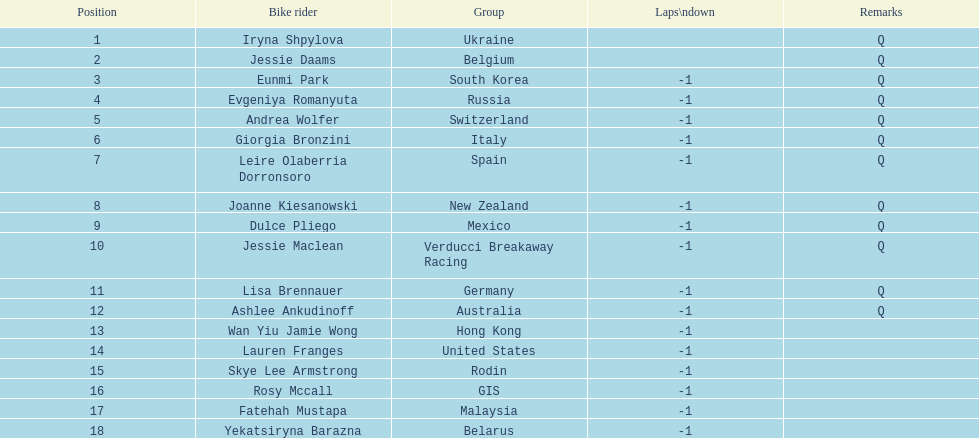How many cyclist are not listed with a country team? 3. 